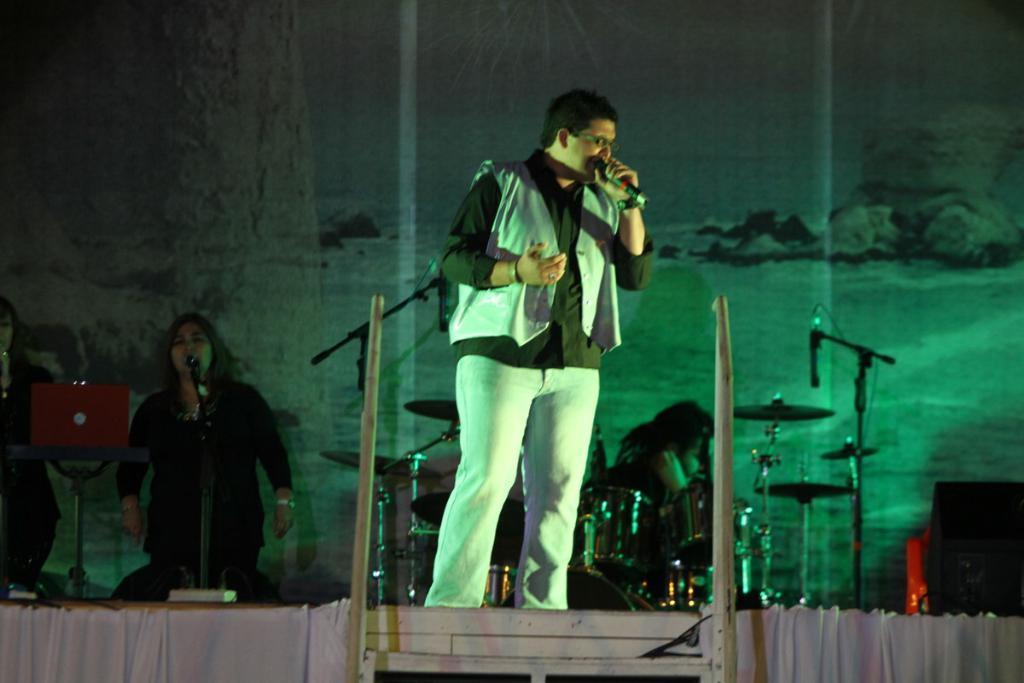Describe this image in one or two sentences. In this image, there are a few people. We can see some microphones, musical instruments and poles. We can also see some white colored cloth at the bottom. We can see the background and some objects on the right. We can see a stand with an object. 